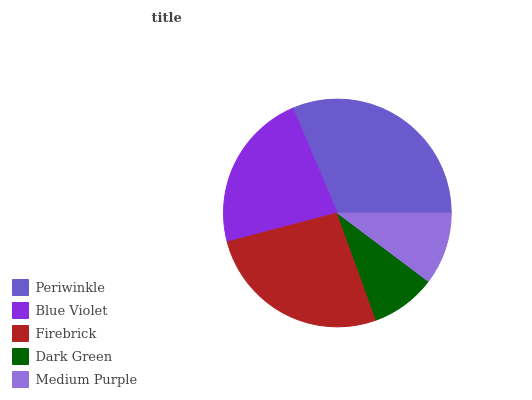Is Dark Green the minimum?
Answer yes or no. Yes. Is Periwinkle the maximum?
Answer yes or no. Yes. Is Blue Violet the minimum?
Answer yes or no. No. Is Blue Violet the maximum?
Answer yes or no. No. Is Periwinkle greater than Blue Violet?
Answer yes or no. Yes. Is Blue Violet less than Periwinkle?
Answer yes or no. Yes. Is Blue Violet greater than Periwinkle?
Answer yes or no. No. Is Periwinkle less than Blue Violet?
Answer yes or no. No. Is Blue Violet the high median?
Answer yes or no. Yes. Is Blue Violet the low median?
Answer yes or no. Yes. Is Periwinkle the high median?
Answer yes or no. No. Is Dark Green the low median?
Answer yes or no. No. 